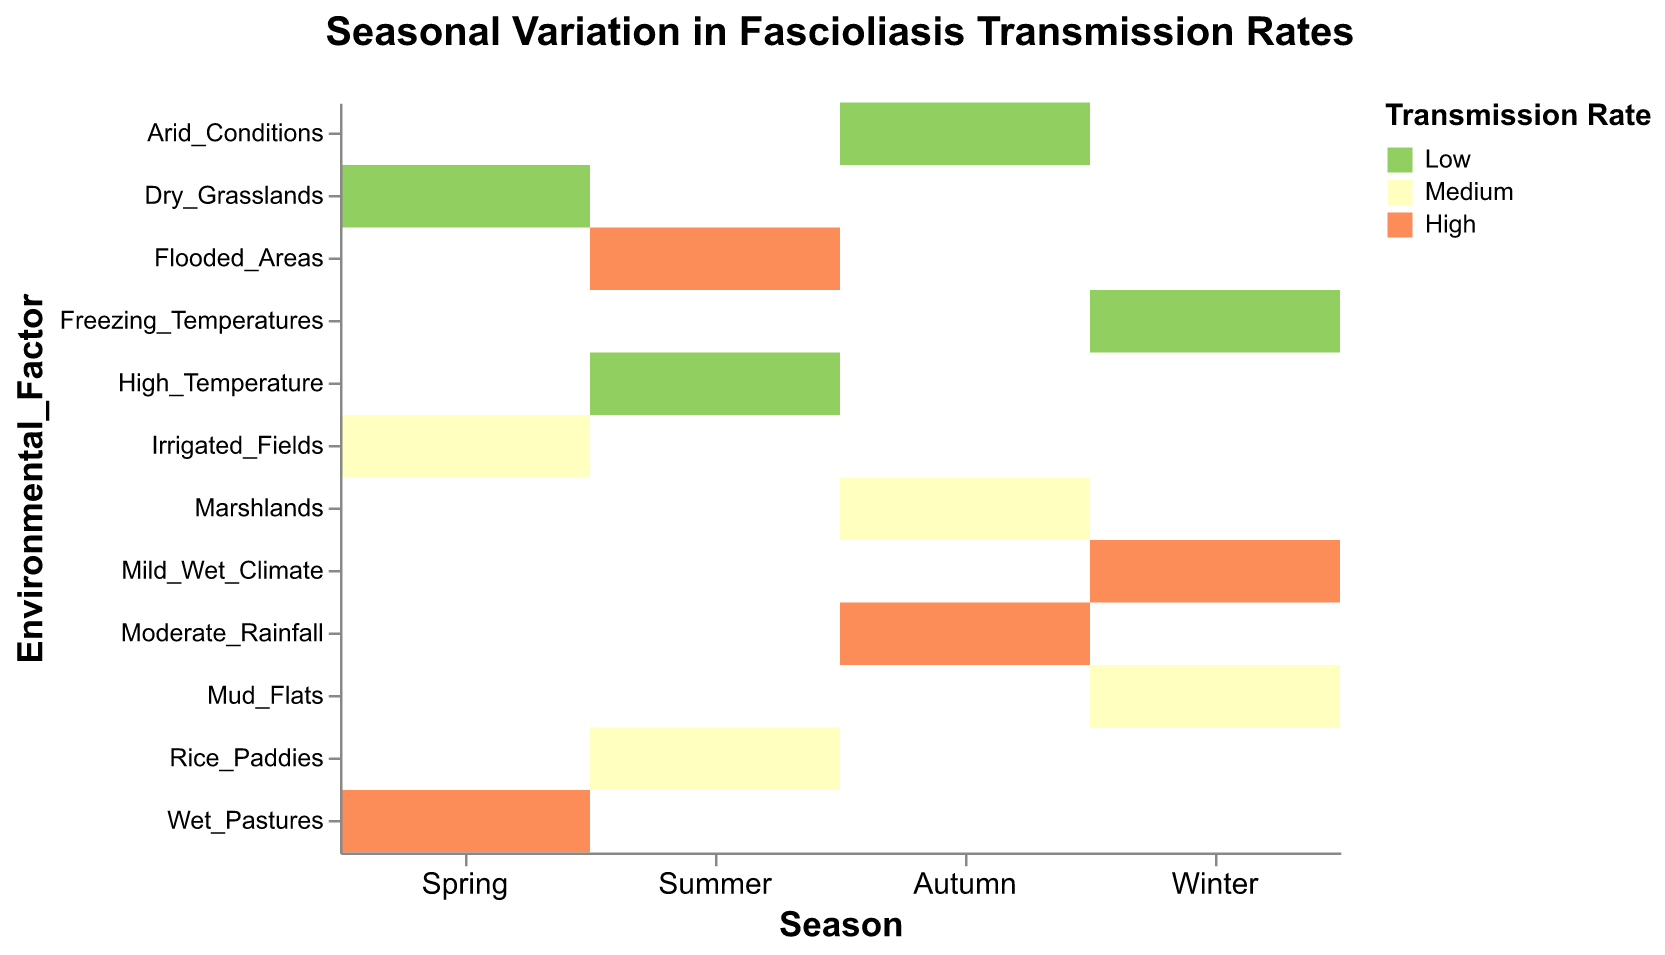What season has the highest transmission rate associated with wet pastures? Look at the row for "Wet_Pastures" and find which season has a cell colored for a high transmission rate. It is in the "Spring" column.
Answer: Spring What is the transmission rate in autumn for marshlands? Locate the autumn column and find the cell that corresponds with marshlands. The color indicates a medium transmission rate.
Answer: Medium How many regions show a high transmission rate in winter? In the winter column, count the number of cells colored to indicate a high transmission rate. There is only one such cell.
Answer: One Which environmental factor appears in the most seasons? Check each environmental factor and count how many unique seasons it appears in. Several factors appear in single seasons, so no factor appears in more than one season.
Answer: None Which season has the highest variation in transmission rates? Check each season’s column to see which one contains the widest range of colors from low to high. All columns contain all three transmission rates, indicating equal variation.
Answer: All Is a flooded area with high transmission rate seen in one or multiple seasons? Find flooded areas in the environmental factors and see the seasons they occur in. It only appears in the "Summer" column.
Answer: One Compare the transmission rates for summer and winter. Which season has more regions with high transmission rates? Count the high transmission rate cells in both summer and winter. Summer has one, while winter also has one.
Answer: Equal What is the transmission rate in Norway during winter with freezing temperatures? Locate the cell in the winter column for the environmental factor "Freezing_Temperatures," which indicates a low transmission rate.
Answer: Low 